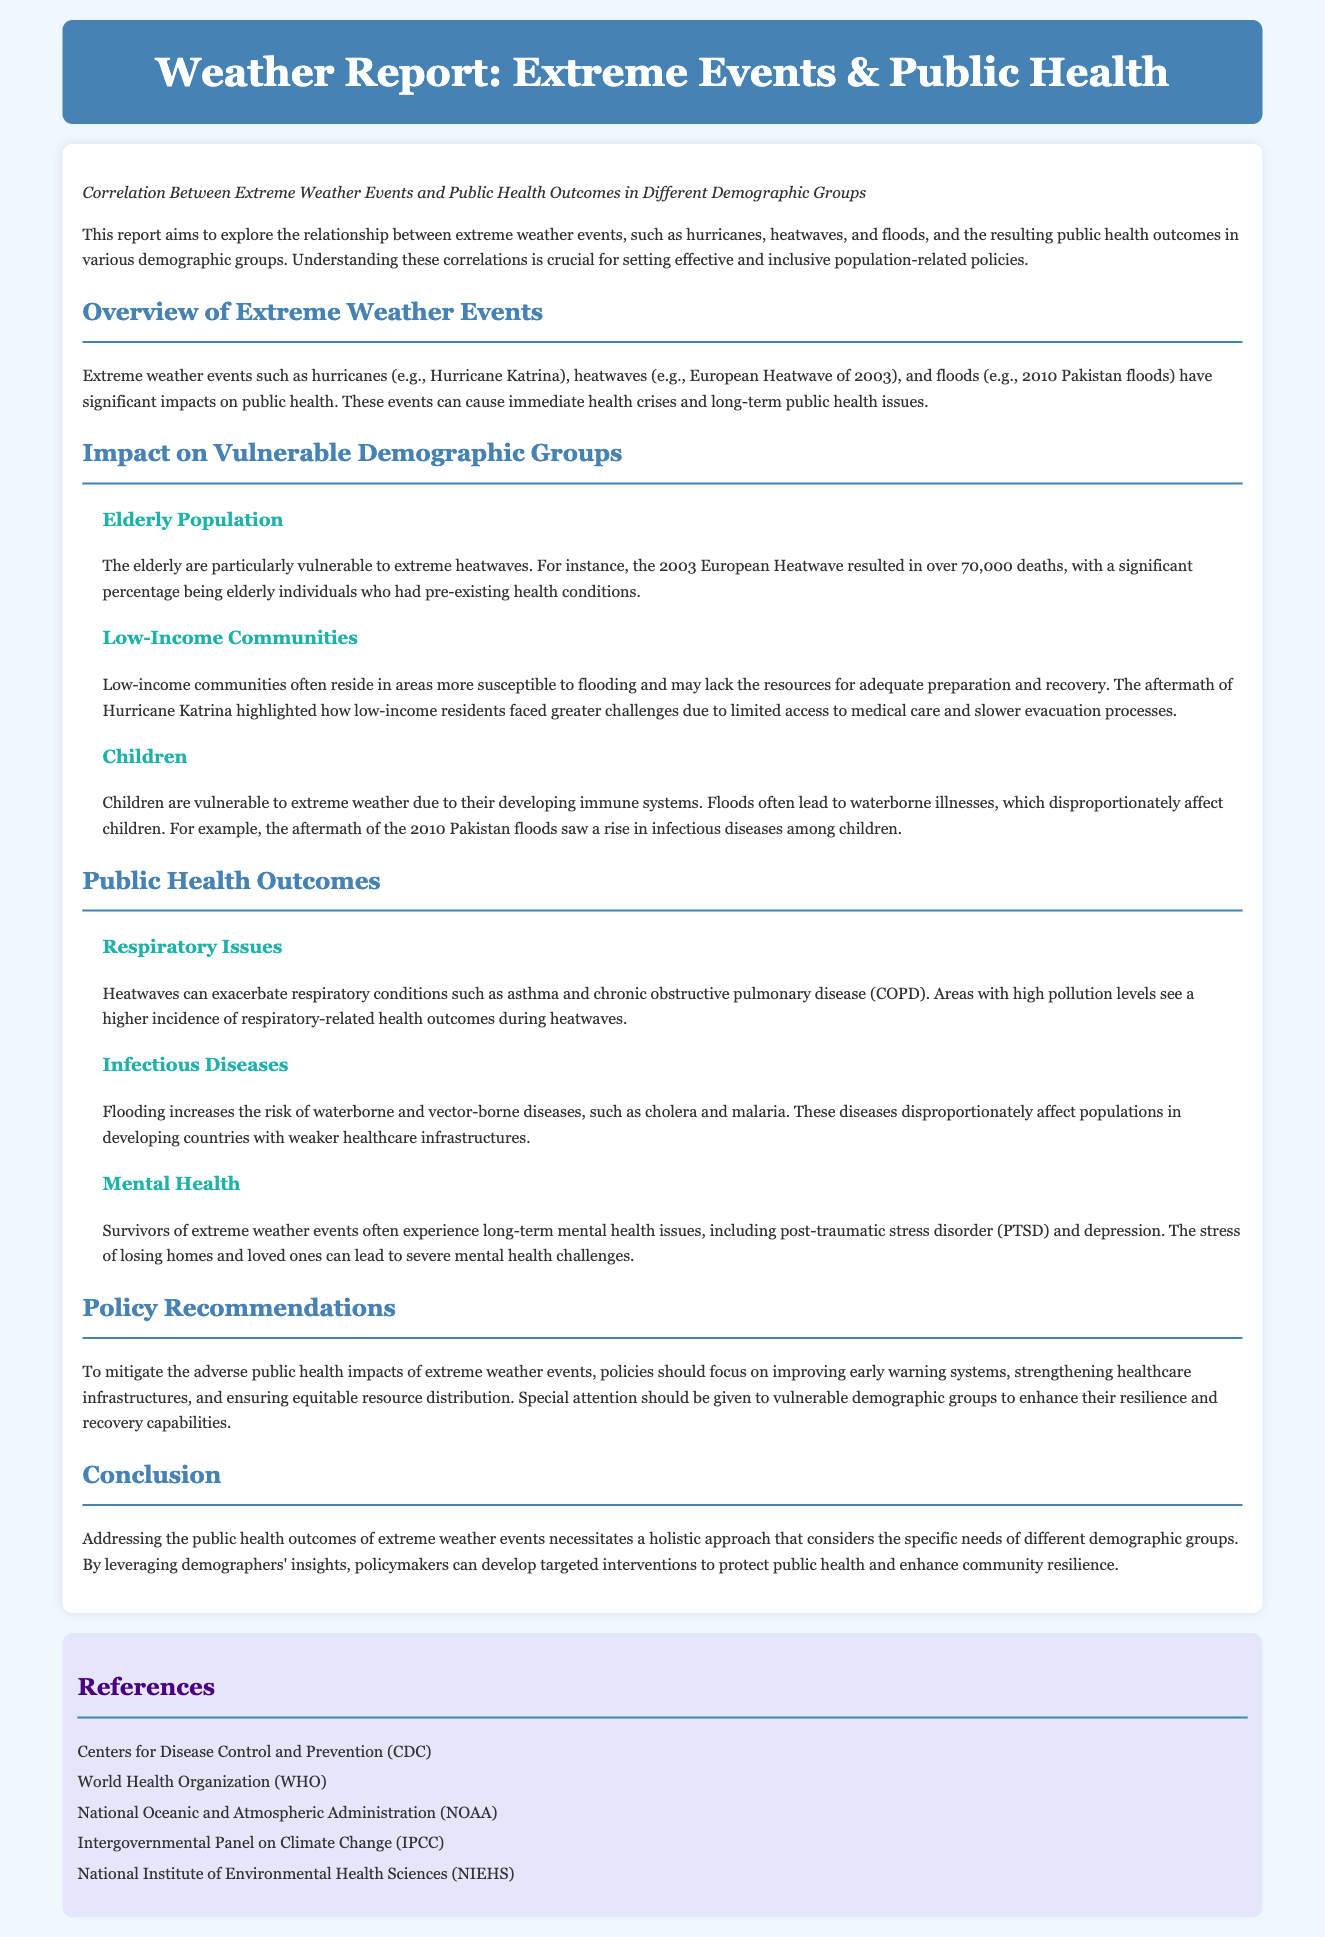What is the report about? The report explores the relationship between extreme weather events and public health outcomes in various demographic groups.
Answer: Correlation Between Extreme Weather Events and Public Health Outcomes in Different Demographic Groups What extreme weather event caused over 70,000 deaths in 2003? The document mentions the 2003 European Heatwave as responsible for over 70,000 deaths, particularly among the elderly.
Answer: European Heatwave Which group is particularly vulnerable to floods? Low-income communities are noted to be particularly vulnerable due to their susceptibility and lack of resources.
Answer: Low-Income Communities What health issue can be exacerbated by heatwaves? The document states that heatwaves can exacerbate respiratory conditions such as asthma and COPD.
Answer: Respiratory issues Which demographics are noted to experience long-term mental health issues after extreme weather events? Survivors of extreme weather events often experience long-term mental health issues, including PTSD and depression.
Answer: Survivors What does the report recommend to improve public health outcomes? The report recommends improving early warning systems and strengthening healthcare infrastructures as key policy actions.
Answer: Improving early warning systems Which demographic is mentioned as being affected by waterborne illnesses? Children are highlighted in the document as particularly vulnerable to waterborne illnesses after floods.
Answer: Children What is a critical aspect of policy recommendations? Special attention should be given to vulnerable demographic groups as part of effective policy recommendations.
Answer: Vulnerable demographic groups 